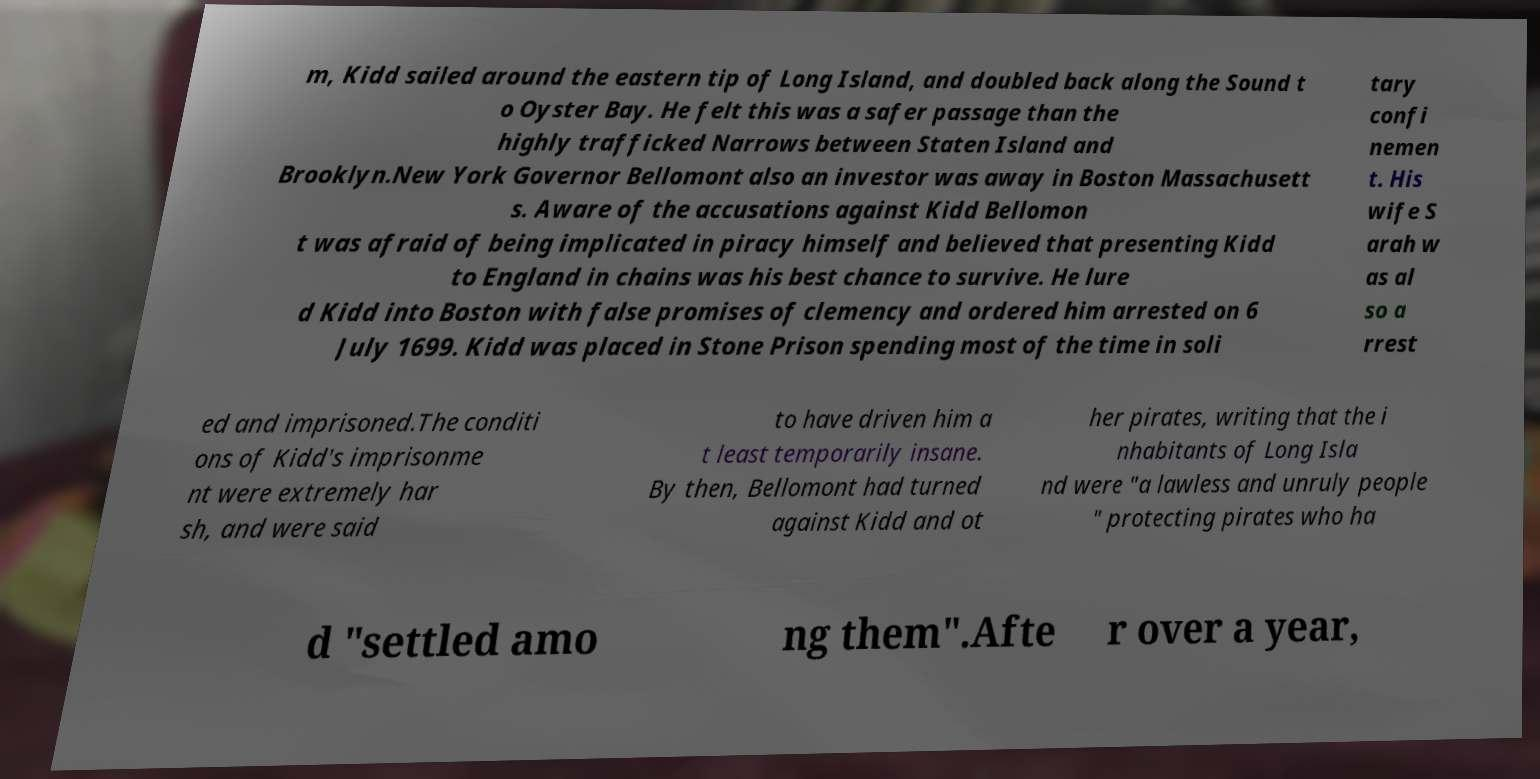Please identify and transcribe the text found in this image. m, Kidd sailed around the eastern tip of Long Island, and doubled back along the Sound t o Oyster Bay. He felt this was a safer passage than the highly trafficked Narrows between Staten Island and Brooklyn.New York Governor Bellomont also an investor was away in Boston Massachusett s. Aware of the accusations against Kidd Bellomon t was afraid of being implicated in piracy himself and believed that presenting Kidd to England in chains was his best chance to survive. He lure d Kidd into Boston with false promises of clemency and ordered him arrested on 6 July 1699. Kidd was placed in Stone Prison spending most of the time in soli tary confi nemen t. His wife S arah w as al so a rrest ed and imprisoned.The conditi ons of Kidd's imprisonme nt were extremely har sh, and were said to have driven him a t least temporarily insane. By then, Bellomont had turned against Kidd and ot her pirates, writing that the i nhabitants of Long Isla nd were "a lawless and unruly people " protecting pirates who ha d "settled amo ng them".Afte r over a year, 